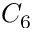Convert formula to latex. <formula><loc_0><loc_0><loc_500><loc_500>C _ { 6 }</formula> 